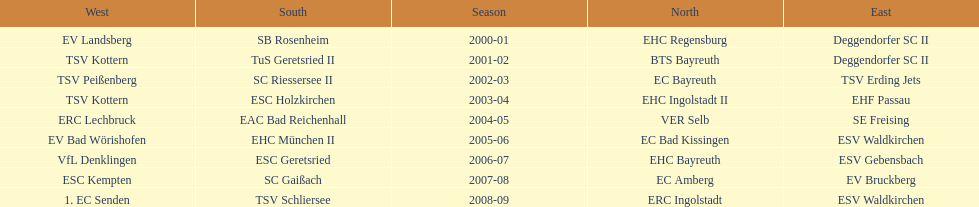How many champions are listend in the north? 9. 